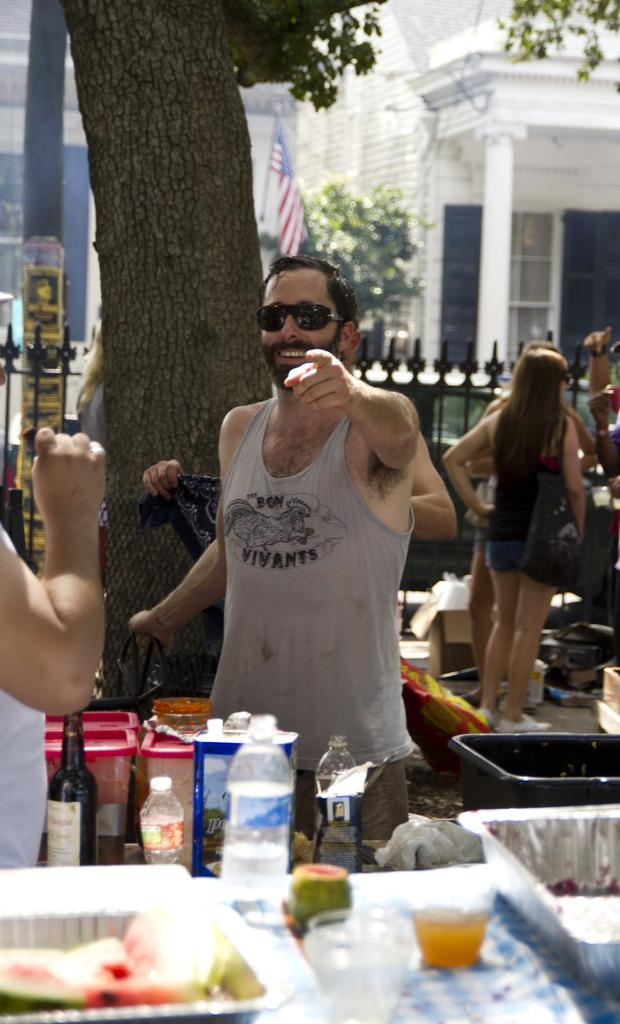How many people are the persons are visible in the image? There are persons standing in the image. What objects are on the table in the image? There is a bottle, a box, food, and a glass on the table. What can be seen in the background of the image? There is a building, a flag, and a tree in the background. What type of pollution is visible in the image? There is no visible pollution in the image. How many girls are present in the image? The provided facts do not mention the gender of the persons in the image, so we cannot determine the number of girls. 